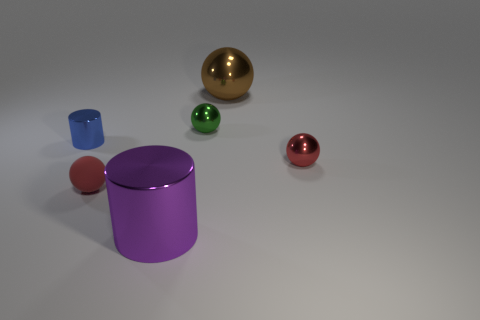Add 2 metallic balls. How many objects exist? 8 Subtract all cylinders. How many objects are left? 4 Subtract all green rubber things. Subtract all balls. How many objects are left? 2 Add 4 metallic objects. How many metallic objects are left? 9 Add 6 tiny yellow metallic cylinders. How many tiny yellow metallic cylinders exist? 6 Subtract 2 red spheres. How many objects are left? 4 